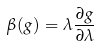Convert formula to latex. <formula><loc_0><loc_0><loc_500><loc_500>\beta ( g ) = \lambda \frac { \partial g } { \partial \lambda }</formula> 